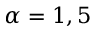<formula> <loc_0><loc_0><loc_500><loc_500>\alpha = 1 , 5</formula> 